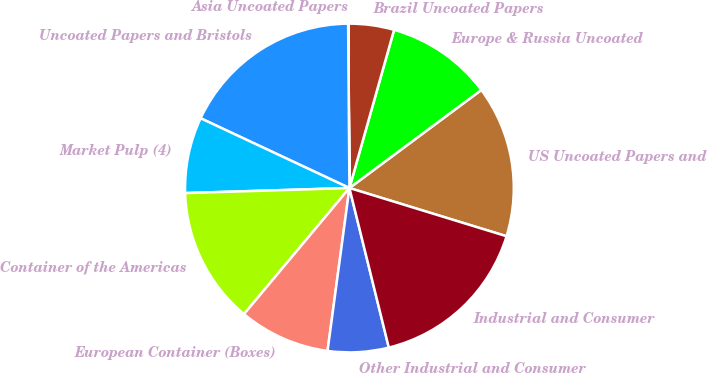Convert chart. <chart><loc_0><loc_0><loc_500><loc_500><pie_chart><fcel>US Uncoated Papers and<fcel>Europe & Russia Uncoated<fcel>Brazil Uncoated Papers<fcel>Asia Uncoated Papers<fcel>Uncoated Papers and Bristols<fcel>Market Pulp (4)<fcel>Container of the Americas<fcel>European Container (Boxes)<fcel>Other Industrial and Consumer<fcel>Industrial and Consumer<nl><fcel>14.92%<fcel>10.45%<fcel>4.49%<fcel>0.02%<fcel>17.9%<fcel>7.47%<fcel>13.43%<fcel>8.96%<fcel>5.98%<fcel>16.41%<nl></chart> 